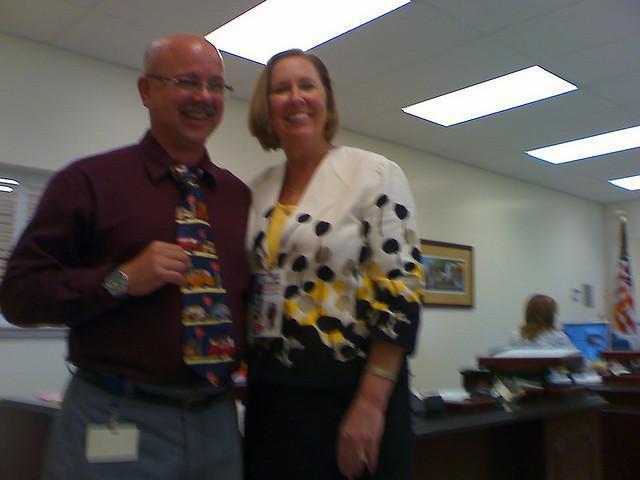How many people are smiling in this picture?
Give a very brief answer. 2. How many people are wearing blue shirts?
Give a very brief answer. 0. How many people are in this picture?
Give a very brief answer. 3. How many people are there?
Give a very brief answer. 3. 